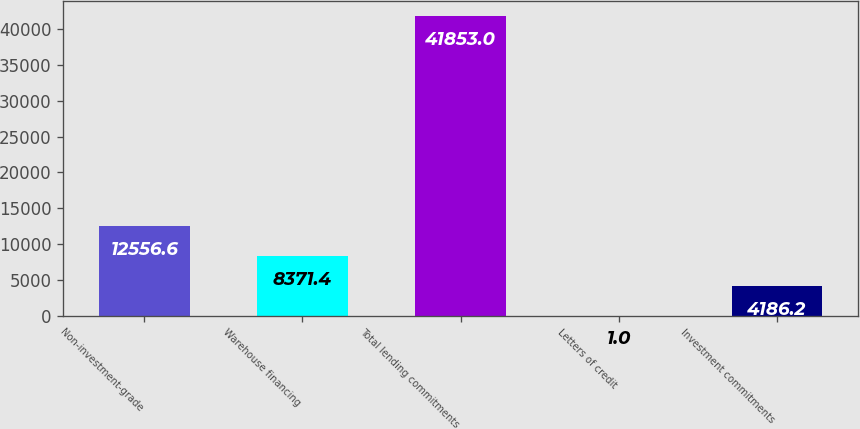<chart> <loc_0><loc_0><loc_500><loc_500><bar_chart><fcel>Non-investment-grade<fcel>Warehouse financing<fcel>Total lending commitments<fcel>Letters of credit<fcel>Investment commitments<nl><fcel>12556.6<fcel>8371.4<fcel>41853<fcel>1<fcel>4186.2<nl></chart> 